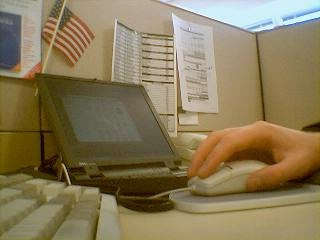Describe the objects in this image and their specific colors. I can see laptop in gray, darkgreen, and black tones, keyboard in gray and olive tones, people in gray, olive, and tan tones, mouse in gray, tan, and olive tones, and keyboard in gray, black, and olive tones in this image. 